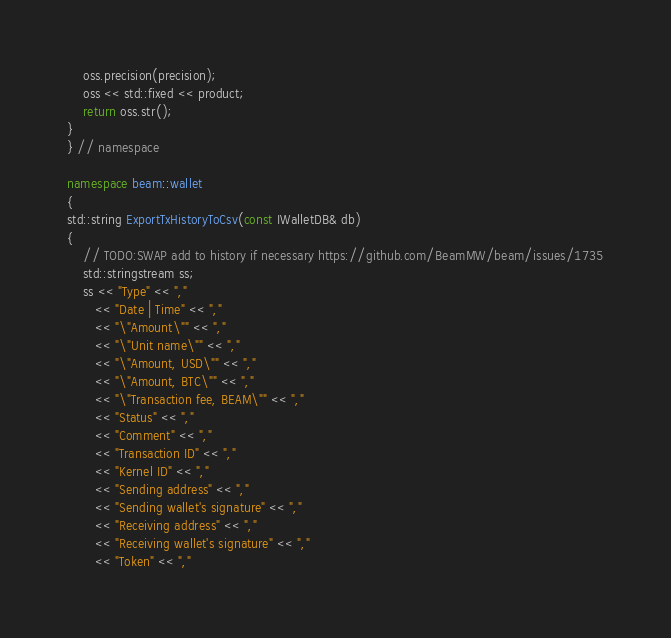Convert code to text. <code><loc_0><loc_0><loc_500><loc_500><_C++_>    oss.precision(precision);
    oss << std::fixed << product;
    return oss.str();
}
} // namespace

namespace beam::wallet
{
std::string ExportTxHistoryToCsv(const IWalletDB& db)
{
    // TODO:SWAP add to history if necessary https://github.com/BeamMW/beam/issues/1735
    std::stringstream ss;
    ss << "Type" << ","
       << "Date | Time" << ","
       << "\"Amount\"" << ","
       << "\"Unit name\"" << ","
       << "\"Amount, USD\"" << ","
       << "\"Amount, BTC\"" << ","
       << "\"Transaction fee, BEAM\"" << ","
       << "Status" << ","
       << "Comment" << "," 
       << "Transaction ID" << ","
       << "Kernel ID" << "," 
       << "Sending address" << ","
       << "Sending wallet's signature" << ","
       << "Receiving address" << ","
       << "Receiving wallet's signature" << ","
       << "Token" << ","</code> 